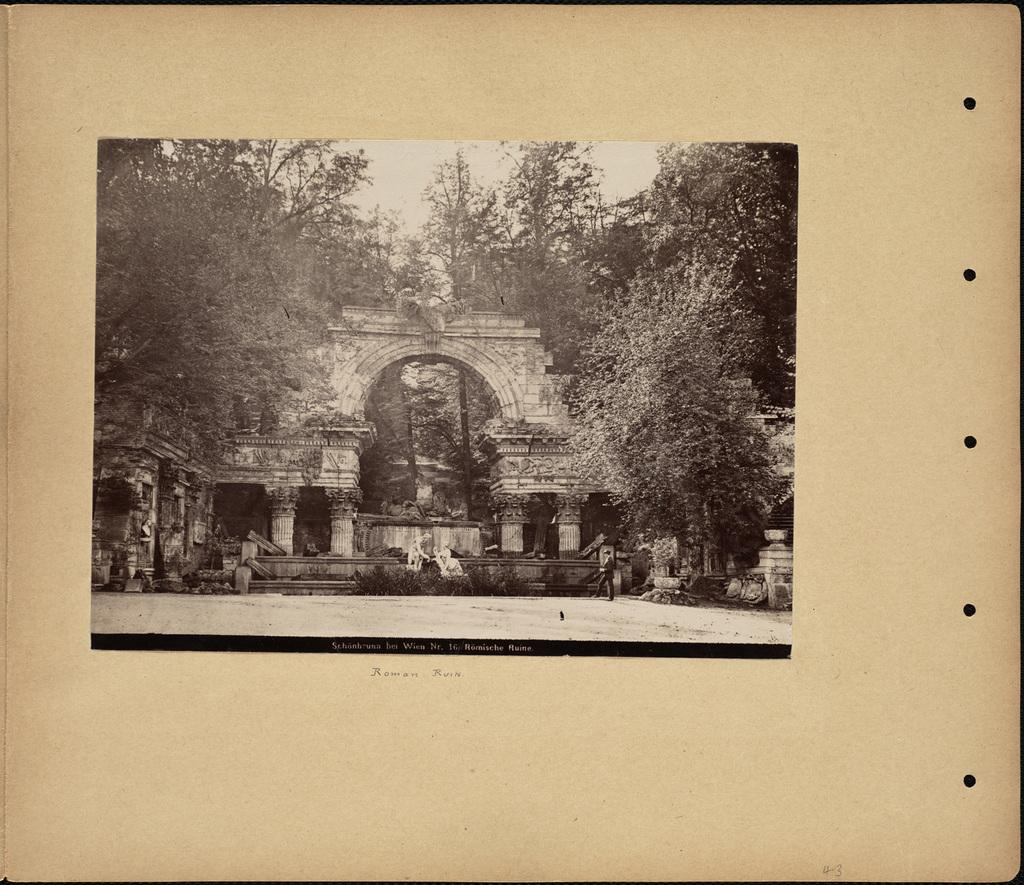What is the main subject of the image? The main subject of the image is a board. What is depicted on the board? The board contains a picture of an arch. What other elements can be seen in the picture? Trees and pillars are visible in the picture. How many pears are hanging from the trees in the image? There are no pears present in the image; it only contains a picture of an arch, trees, and pillars. 